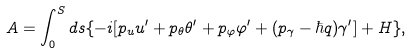<formula> <loc_0><loc_0><loc_500><loc_500>A = \int _ { 0 } ^ { S } d s \{ - i [ p _ { u } u ^ { \prime } + p _ { \theta } \theta ^ { \prime } + p _ { \varphi } \varphi ^ { \prime } + ( p _ { \gamma } - \hbar { q } ) \gamma ^ { \prime } ] + H \} ,</formula> 